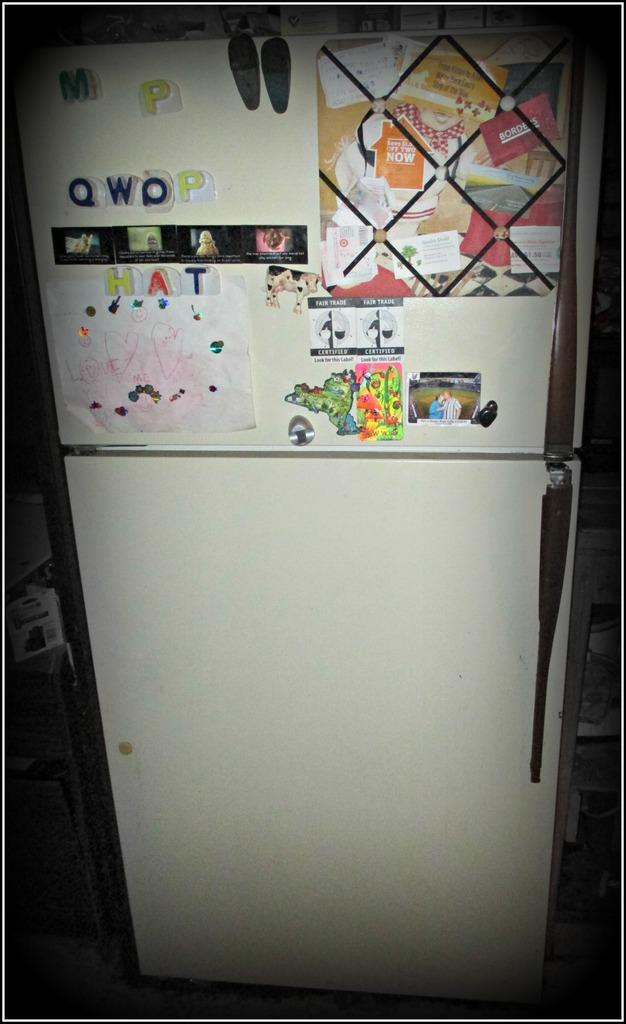<image>
Create a compact narrative representing the image presented. A fridge with large letters that read QWOP and HAT. 